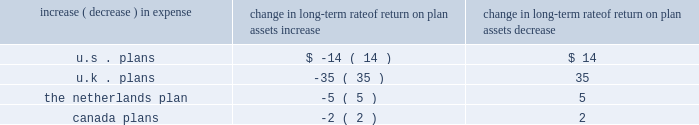Holding other assumptions constant , the table reflects what a one hundred basis point increase and decrease in our estimated long-term rate of return on plan assets would have on our estimated 2011 pension expense ( in millions ) : change in long-term rate of return on plan assets .
Estimated future contributions we estimate contributions of approximately $ 403 million in 2011 as compared with $ 288 million in goodwill and other intangible assets goodwill represents the excess of cost over the fair market value of the net assets acquired .
We classify our intangible assets acquired as either trademarks , customer relationships , technology , non-compete agreements , or other purchased intangibles .
Our goodwill and other intangible balances at december 31 , 2010 increased to $ 8.6 billion and $ 3.6 billion , respectively , compared to $ 6.1 billion and $ 791 million , respectively , at december 31 , 2009 , primarily as a result of the hewitt acquisition .
Although goodwill is not amortized , we test it for impairment at least annually in the fourth quarter .
In the fourth quarter , we also test acquired trademarks ( which also are not amortized ) for impairment .
We test more frequently if there are indicators of impairment or whenever business circumstances suggest that the carrying value of goodwill or trademarks may not be recoverable .
These indicators may include a sustained significant decline in our share price and market capitalization , a decline in our expected future cash flows , or a significant adverse change in legal factors or in the business climate , among others .
No events occurred during 2010 or 2009 that indicate the existence of an impairment with respect to our reported goodwill or trademarks .
We perform impairment reviews at the reporting unit level .
A reporting unit is an operating segment or one level below an operating segment ( referred to as a 2018 2018component 2019 2019 ) .
A component of an operating segment is a reporting unit if the component constitutes a business for which discrete financial information is available and segment management regularly reviews the operating results of that component .
An operating segment shall be deemed to be a reporting unit if all of its components are similar , if none of its components is a reporting unit , or if the segment comprises only a single component .
The goodwill impairment test is a two step analysis .
Step one requires the fair value of each reporting unit to be compared to its book value .
Management must apply judgment in determining the estimated fair value of the reporting units .
If the fair value of a reporting unit is determined to be greater than the carrying value of the reporting unit , goodwill and trademarks are deemed not to be impaired and no further testing is necessary .
If the fair value of a reporting unit is less than the carrying value , we perform step two .
Step two uses the calculated fair value of the reporting unit to perform a hypothetical purchase price allocation to the fair value of the assets and liabilities of the reporting unit .
The difference between the fair value of the reporting unit calculated in step one and the fair value of the underlying assets and liabilities of the reporting unit is the implied fair value of the reporting unit 2019s goodwill .
A charge is recorded in the financial statements if the carrying value of the reporting unit 2019s goodwill is greater than its implied fair value. .
What is the total change in long-term rate of return on plan assets if there is an decrease of one hundred basis point? 
Computations: (((14 + 35) + 5) + 2)
Answer: 56.0. Holding other assumptions constant , the table reflects what a one hundred basis point increase and decrease in our estimated long-term rate of return on plan assets would have on our estimated 2011 pension expense ( in millions ) : change in long-term rate of return on plan assets .
Estimated future contributions we estimate contributions of approximately $ 403 million in 2011 as compared with $ 288 million in goodwill and other intangible assets goodwill represents the excess of cost over the fair market value of the net assets acquired .
We classify our intangible assets acquired as either trademarks , customer relationships , technology , non-compete agreements , or other purchased intangibles .
Our goodwill and other intangible balances at december 31 , 2010 increased to $ 8.6 billion and $ 3.6 billion , respectively , compared to $ 6.1 billion and $ 791 million , respectively , at december 31 , 2009 , primarily as a result of the hewitt acquisition .
Although goodwill is not amortized , we test it for impairment at least annually in the fourth quarter .
In the fourth quarter , we also test acquired trademarks ( which also are not amortized ) for impairment .
We test more frequently if there are indicators of impairment or whenever business circumstances suggest that the carrying value of goodwill or trademarks may not be recoverable .
These indicators may include a sustained significant decline in our share price and market capitalization , a decline in our expected future cash flows , or a significant adverse change in legal factors or in the business climate , among others .
No events occurred during 2010 or 2009 that indicate the existence of an impairment with respect to our reported goodwill or trademarks .
We perform impairment reviews at the reporting unit level .
A reporting unit is an operating segment or one level below an operating segment ( referred to as a 2018 2018component 2019 2019 ) .
A component of an operating segment is a reporting unit if the component constitutes a business for which discrete financial information is available and segment management regularly reviews the operating results of that component .
An operating segment shall be deemed to be a reporting unit if all of its components are similar , if none of its components is a reporting unit , or if the segment comprises only a single component .
The goodwill impairment test is a two step analysis .
Step one requires the fair value of each reporting unit to be compared to its book value .
Management must apply judgment in determining the estimated fair value of the reporting units .
If the fair value of a reporting unit is determined to be greater than the carrying value of the reporting unit , goodwill and trademarks are deemed not to be impaired and no further testing is necessary .
If the fair value of a reporting unit is less than the carrying value , we perform step two .
Step two uses the calculated fair value of the reporting unit to perform a hypothetical purchase price allocation to the fair value of the assets and liabilities of the reporting unit .
The difference between the fair value of the reporting unit calculated in step one and the fair value of the underlying assets and liabilities of the reporting unit is the implied fair value of the reporting unit 2019s goodwill .
A charge is recorded in the financial statements if the carrying value of the reporting unit 2019s goodwill is greater than its implied fair value. .
What was the percentage change in the goodwill in 2010 as a result of the hewitt acquisition .? 
Computations: ((8.6 - 6.1) / 6.1)
Answer: 0.40984. 